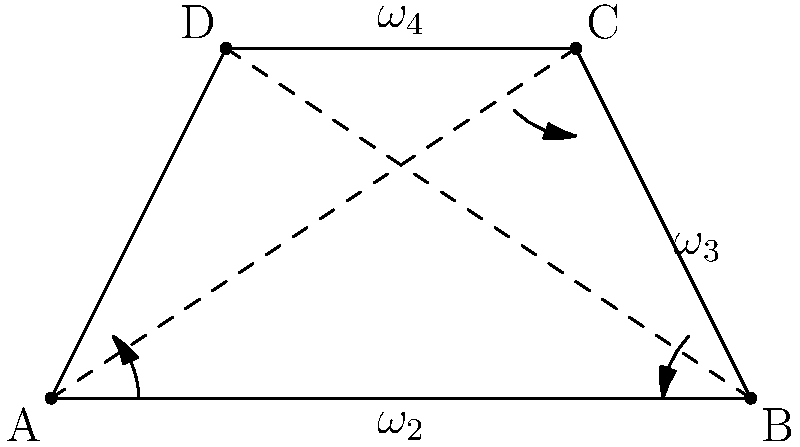In the four-bar linkage mechanism shown, link AB is the input link rotating with an angular velocity $\omega_2 = 5$ rad/s clockwise. If the lengths of the links are AB = 4 units, BC = 2.24 units, CD = 2 units, and DA = 2.24 units, determine the angular velocity of link CD ($\omega_4$) when link AB is horizontal. How does this analysis contribute to understanding the dynamics of mechanical systems in the context of engineering advancements that have historically been influenced by African American inventors? To solve this problem, we'll use the velocity analysis method for four-bar linkages. This method is crucial in understanding the dynamics of mechanical systems, which have been influenced by various inventors, including notable African American engineers throughout history.

Step 1: Identify the instant center of rotation (IC) for the coupler link BC.
The IC is located at the intersection of lines AD and BC extended.

Step 2: Apply the Kennedy's Theorem.
This theorem states that the velocity of any point on a rigid body is perpendicular to the line joining that point to the instantaneous center of rotation.

Step 3: Draw velocity vectors.
- $v_B$ is perpendicular to AB
- $v_C$ is perpendicular to DC

Step 4: Write the velocity equations.
$$v_B = \omega_2 \cdot AB = 5 \cdot 4 = 20 \text{ units/s}$$
$$\frac{v_C}{CD} = \frac{v_B}{AB}$$

Step 5: Solve for $v_C$.
$$v_C = \frac{v_B \cdot CD}{AB} = \frac{20 \cdot 2}{4} = 10 \text{ units/s}$$

Step 6: Calculate $\omega_4$.
$$\omega_4 = \frac{v_C}{CD} = \frac{10}{2} = 5 \text{ rad/s}$$

This analysis demonstrates the application of fundamental mechanical engineering principles in understanding complex mechanisms. It's worth noting that such analytical techniques have been built upon and advanced by diverse contributors to the field, including African American engineers who have made significant strides in mechanical engineering and robotics.
Answer: $\omega_4 = 5$ rad/s counterclockwise 